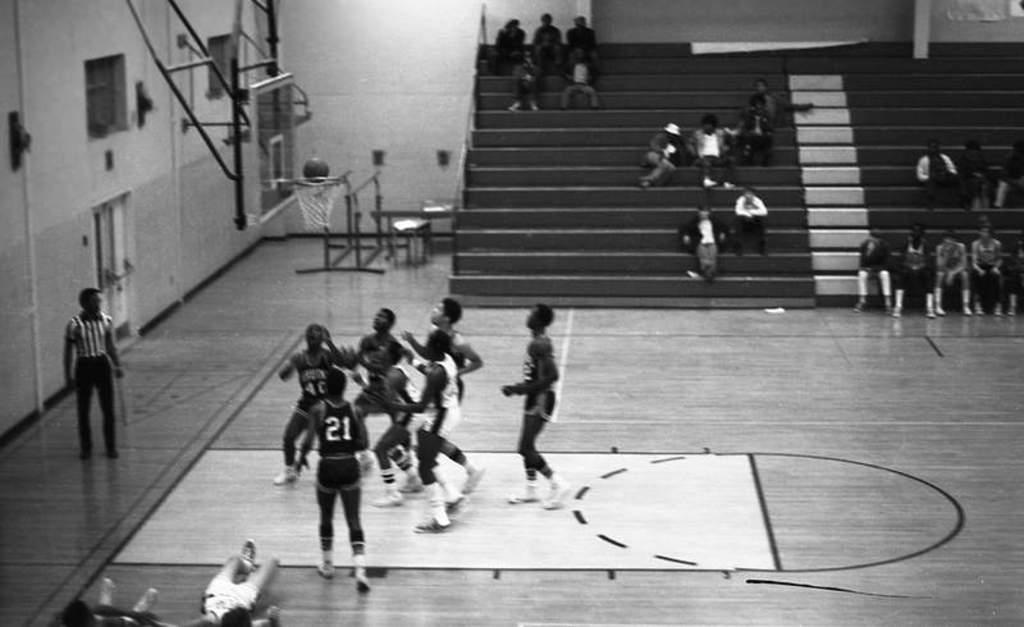<image>
Write a terse but informative summary of the picture. A man wearing jersey number 21 is playing ball 